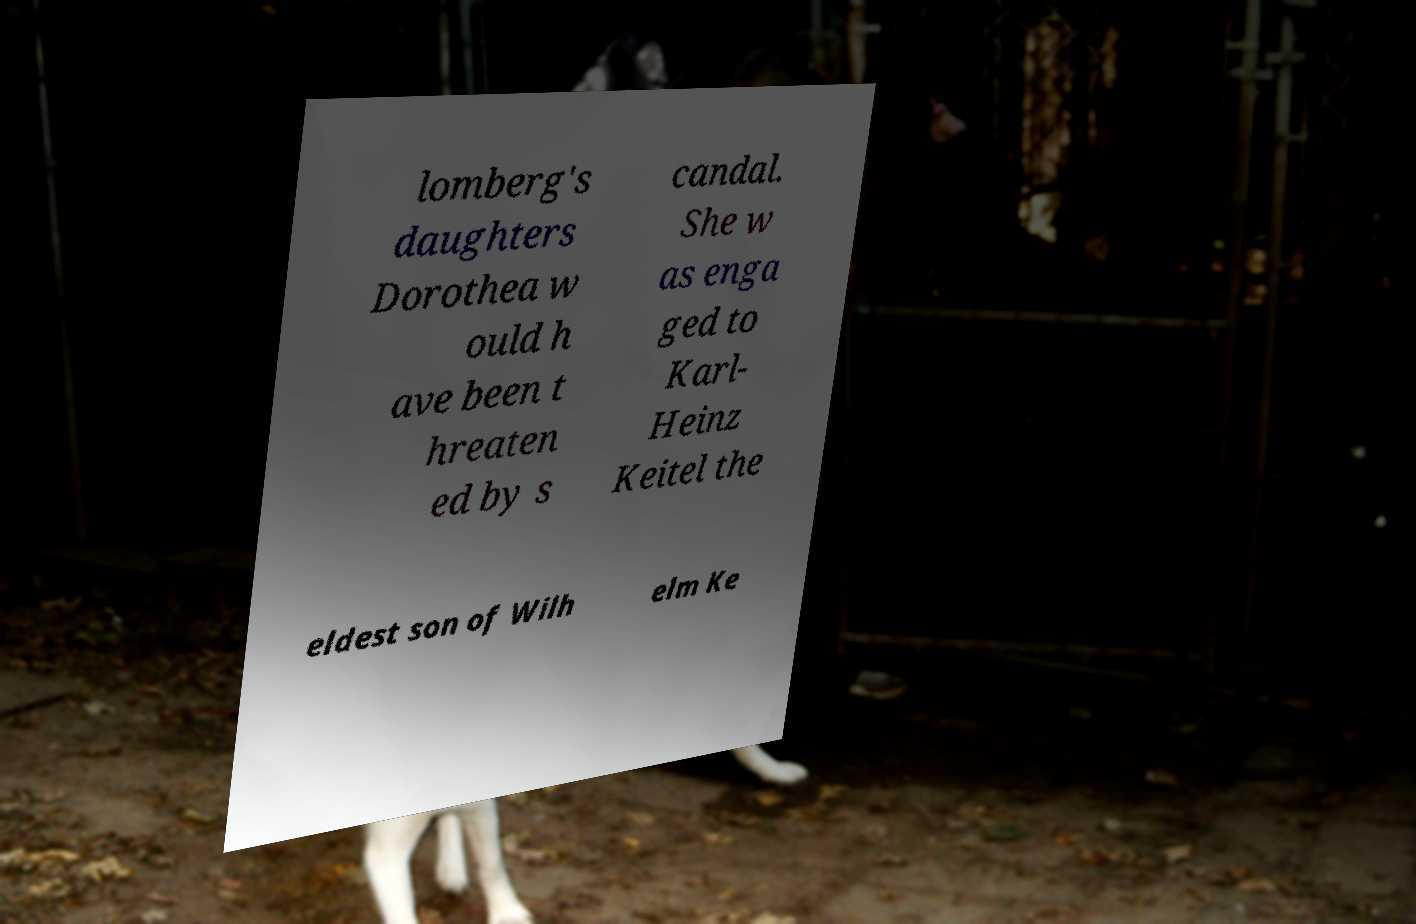Can you accurately transcribe the text from the provided image for me? lomberg's daughters Dorothea w ould h ave been t hreaten ed by s candal. She w as enga ged to Karl- Heinz Keitel the eldest son of Wilh elm Ke 